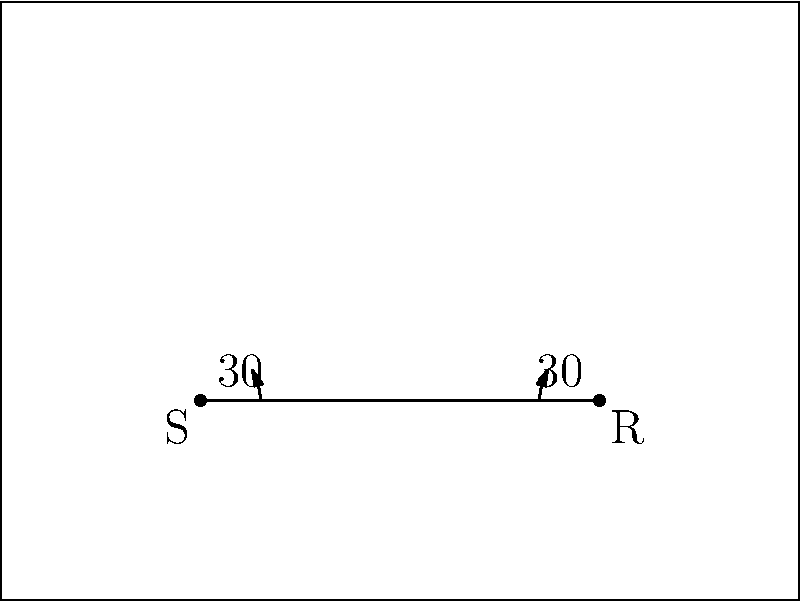In a recording studio, a sound wave is emitted from a source S and reflects off a flat wall before reaching a receiver R. If the angle of incidence is 30°, what is the total distance traveled by the sound wave from S to R? Let's approach this step-by-step:

1) In sound reflection, the angle of incidence equals the angle of reflection. So, both angles are 30°.

2) The path of the sound wave forms an isosceles triangle, where the wall forms the base.

3) Let's divide this isosceles triangle into two right triangles. Each right triangle has a 30° angle at the wall.

4) In a 30-60-90 triangle, if the shortest side (opposite to 30°) is x, then the hypotenuse is 2x, and the remaining side is $x\sqrt{3}$.

5) From the diagram, we can see that the distance from S to the wall (and R to the wall) is 1 unit.

6) If 1 unit is the shortest side (x) in our 30-60-90 triangle, then the hypotenuse (path of sound wave) must be 2 units.

7) The total path is composed of two such hypotenuses, one from S to the wall, and one from the wall to R.

Therefore, the total distance traveled by the sound wave is 2 + 2 = 4 units.
Answer: 4 units 